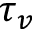Convert formula to latex. <formula><loc_0><loc_0><loc_500><loc_500>\tau _ { v }</formula> 